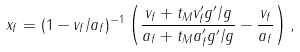<formula> <loc_0><loc_0><loc_500><loc_500>x _ { f } = ( 1 - v _ { f } / a _ { f } ) ^ { - 1 } \left ( \frac { v _ { f } + t _ { M } v ^ { \prime } _ { f } g ^ { \prime } / g } { a _ { f } + t _ { M } a ^ { \prime } _ { f } g ^ { \prime } / g } - \frac { v _ { f } } { a _ { f } } \right ) ,</formula> 